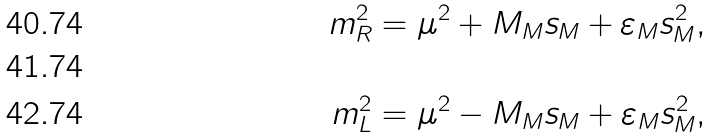Convert formula to latex. <formula><loc_0><loc_0><loc_500><loc_500>m _ { R } ^ { 2 } & = \mu ^ { 2 } + M _ { M } s _ { M } + \varepsilon _ { M } s _ { M } ^ { 2 } , \\ & \\ m _ { L } ^ { 2 } & = \mu ^ { 2 } - M _ { M } s _ { M } + \varepsilon _ { M } s _ { M } ^ { 2 } ,</formula> 